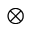Convert formula to latex. <formula><loc_0><loc_0><loc_500><loc_500>\otimes</formula> 